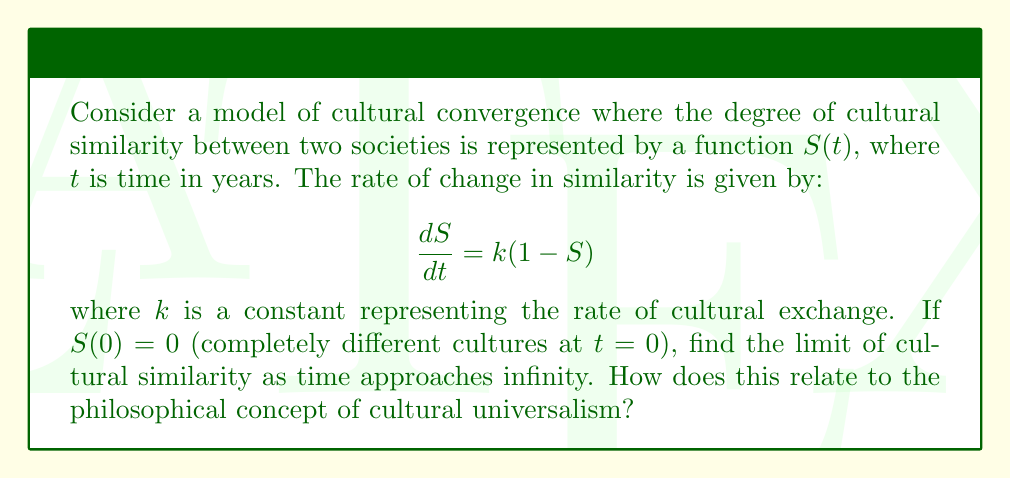Help me with this question. 1) First, we need to solve the differential equation:
   
   $$\frac{dS}{dt} = k(1-S)$$

2) This is a separable differential equation. Let's rearrange it:
   
   $$\frac{dS}{1-S} = k dt$$

3) Integrate both sides:
   
   $$\int \frac{dS}{1-S} = \int k dt$$

4) This gives us:
   
   $$-\ln|1-S| = kt + C$$

5) Solve for $S$:
   
   $$1-S = e^{-(kt+C)} = Ae^{-kt}$$
   $$S = 1 - Ae^{-kt}$$

6) Use the initial condition $S(0) = 0$ to find $A$:
   
   $$0 = 1 - A$$
   $$A = 1$$

7) Therefore, the solution is:
   
   $$S(t) = 1 - e^{-kt}$$

8) To find the limit as $t$ approaches infinity:
   
   $$\lim_{t \to \infty} S(t) = \lim_{t \to \infty} (1 - e^{-kt}) = 1 - \lim_{t \to \infty} e^{-kt} = 1 - 0 = 1$$

9) This result shows that as time approaches infinity, the cultural similarity approaches 1, indicating complete convergence.

10) From a philosophical perspective, this model supports the idea of cultural universalism, suggesting that given enough time and interaction, diverse cultural traditions will converge towards a universal set of values or practices. However, this simplistic model doesn't account for the complexity and resilience of cultural differences in reality.
Answer: $\lim_{t \to \infty} S(t) = 1$ 